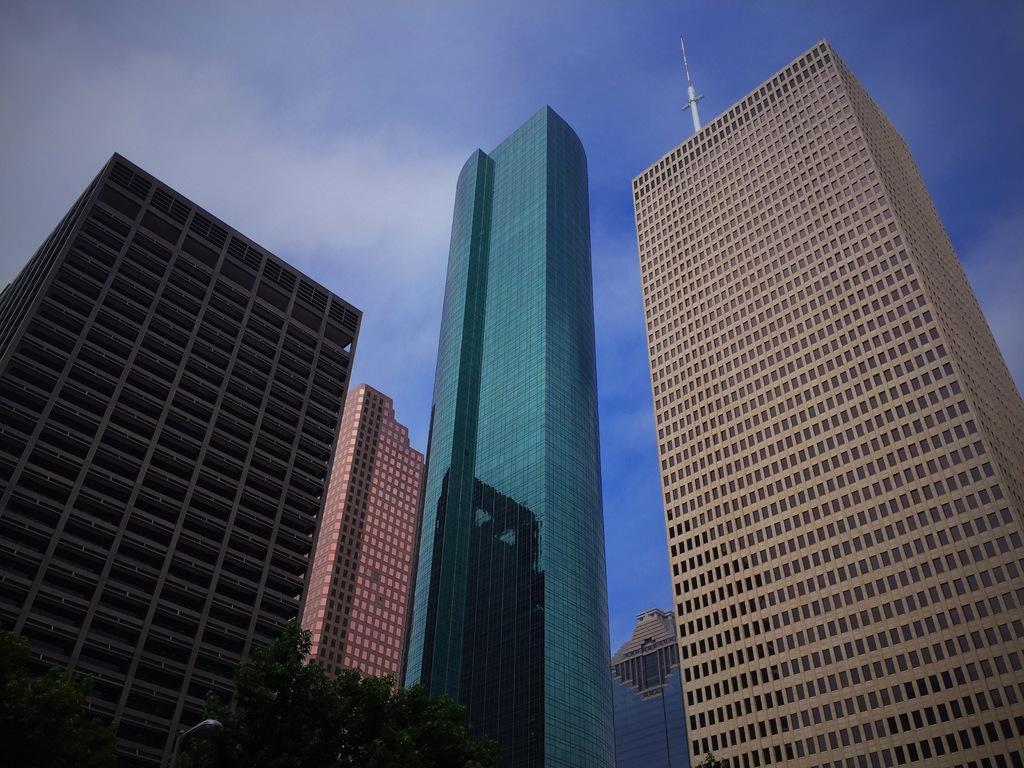Could you give a brief overview of what you see in this image? In this image we can see big buildings, glass doors, at the bottom trees and a street light. In the background we can see a pole and clouds in the sky. 